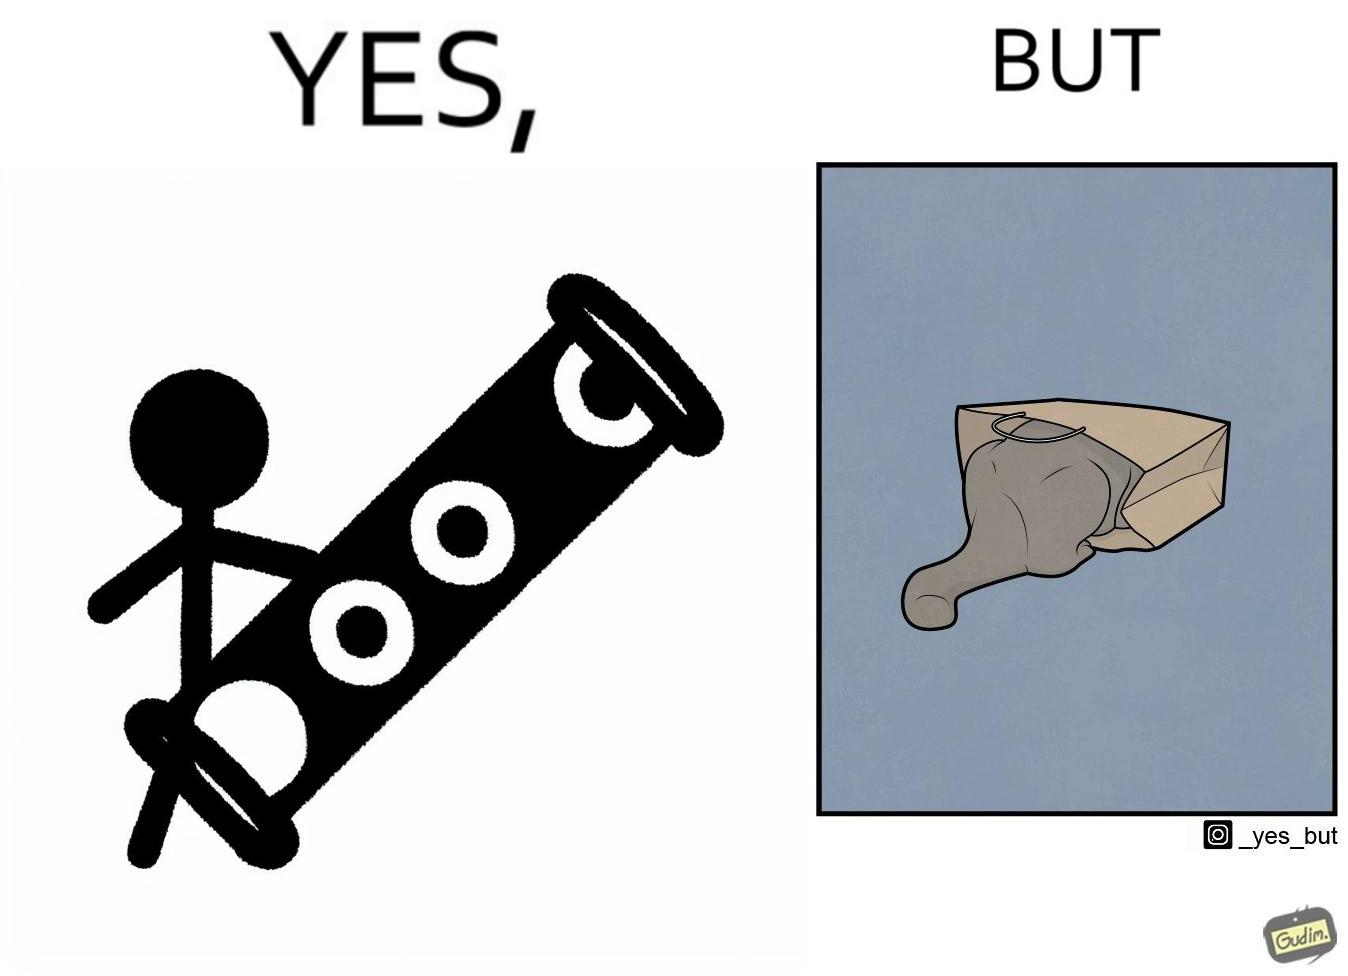Describe the satirical element in this image. The image is funny, because even when there is a dedicated thing for the animal to play with it still is hiding itself in the paper bag 